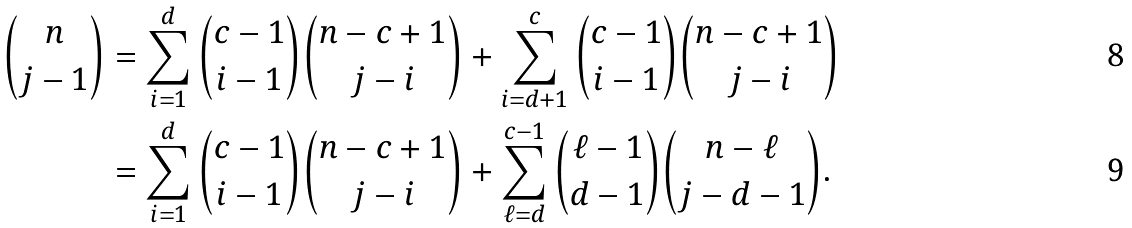<formula> <loc_0><loc_0><loc_500><loc_500>{ n \choose j - 1 } & = \sum _ { i = 1 } ^ { d } { c - 1 \choose i - 1 } { n - c + 1 \choose j - i } + \sum _ { i = d + 1 } ^ { c } { c - 1 \choose i - 1 } { n - c + 1 \choose j - i } \\ & = \sum _ { i = 1 } ^ { d } { c - 1 \choose i - 1 } { n - c + 1 \choose j - i } + \sum _ { \ell = d } ^ { c - 1 } { \ell - 1 \choose d - 1 } { n - \ell \choose j - d - 1 } .</formula> 